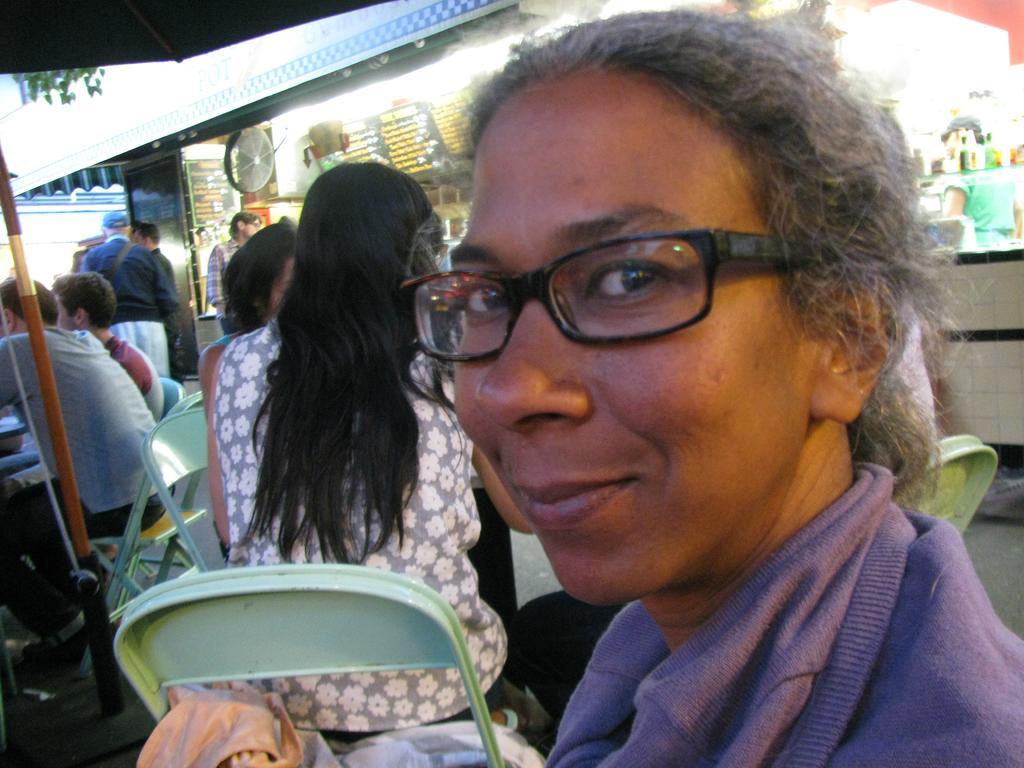Please provide a concise description of this image. On the right side, there is a woman wearing a spectacle and smiling. In the background, there are persons. Some of them are sitting on chairs, there is a pole, a building and other objects. 